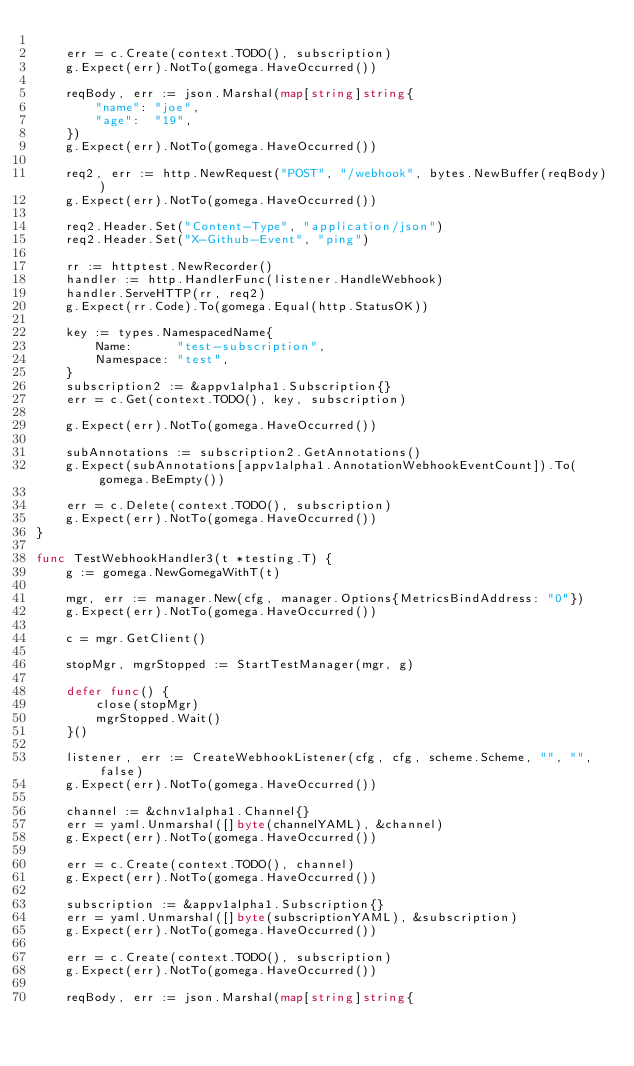Convert code to text. <code><loc_0><loc_0><loc_500><loc_500><_Go_>
	err = c.Create(context.TODO(), subscription)
	g.Expect(err).NotTo(gomega.HaveOccurred())

	reqBody, err := json.Marshal(map[string]string{
		"name": "joe",
		"age":  "19",
	})
	g.Expect(err).NotTo(gomega.HaveOccurred())

	req2, err := http.NewRequest("POST", "/webhook", bytes.NewBuffer(reqBody))
	g.Expect(err).NotTo(gomega.HaveOccurred())

	req2.Header.Set("Content-Type", "application/json")
	req2.Header.Set("X-Github-Event", "ping")

	rr := httptest.NewRecorder()
	handler := http.HandlerFunc(listener.HandleWebhook)
	handler.ServeHTTP(rr, req2)
	g.Expect(rr.Code).To(gomega.Equal(http.StatusOK))

	key := types.NamespacedName{
		Name:      "test-subscription",
		Namespace: "test",
	}
	subscription2 := &appv1alpha1.Subscription{}
	err = c.Get(context.TODO(), key, subscription)

	g.Expect(err).NotTo(gomega.HaveOccurred())

	subAnnotations := subscription2.GetAnnotations()
	g.Expect(subAnnotations[appv1alpha1.AnnotationWebhookEventCount]).To(gomega.BeEmpty())

	err = c.Delete(context.TODO(), subscription)
	g.Expect(err).NotTo(gomega.HaveOccurred())
}

func TestWebhookHandler3(t *testing.T) {
	g := gomega.NewGomegaWithT(t)

	mgr, err := manager.New(cfg, manager.Options{MetricsBindAddress: "0"})
	g.Expect(err).NotTo(gomega.HaveOccurred())

	c = mgr.GetClient()

	stopMgr, mgrStopped := StartTestManager(mgr, g)

	defer func() {
		close(stopMgr)
		mgrStopped.Wait()
	}()

	listener, err := CreateWebhookListener(cfg, cfg, scheme.Scheme, "", "", false)
	g.Expect(err).NotTo(gomega.HaveOccurred())

	channel := &chnv1alpha1.Channel{}
	err = yaml.Unmarshal([]byte(channelYAML), &channel)
	g.Expect(err).NotTo(gomega.HaveOccurred())

	err = c.Create(context.TODO(), channel)
	g.Expect(err).NotTo(gomega.HaveOccurred())

	subscription := &appv1alpha1.Subscription{}
	err = yaml.Unmarshal([]byte(subscriptionYAML), &subscription)
	g.Expect(err).NotTo(gomega.HaveOccurred())

	err = c.Create(context.TODO(), subscription)
	g.Expect(err).NotTo(gomega.HaveOccurred())

	reqBody, err := json.Marshal(map[string]string{</code> 